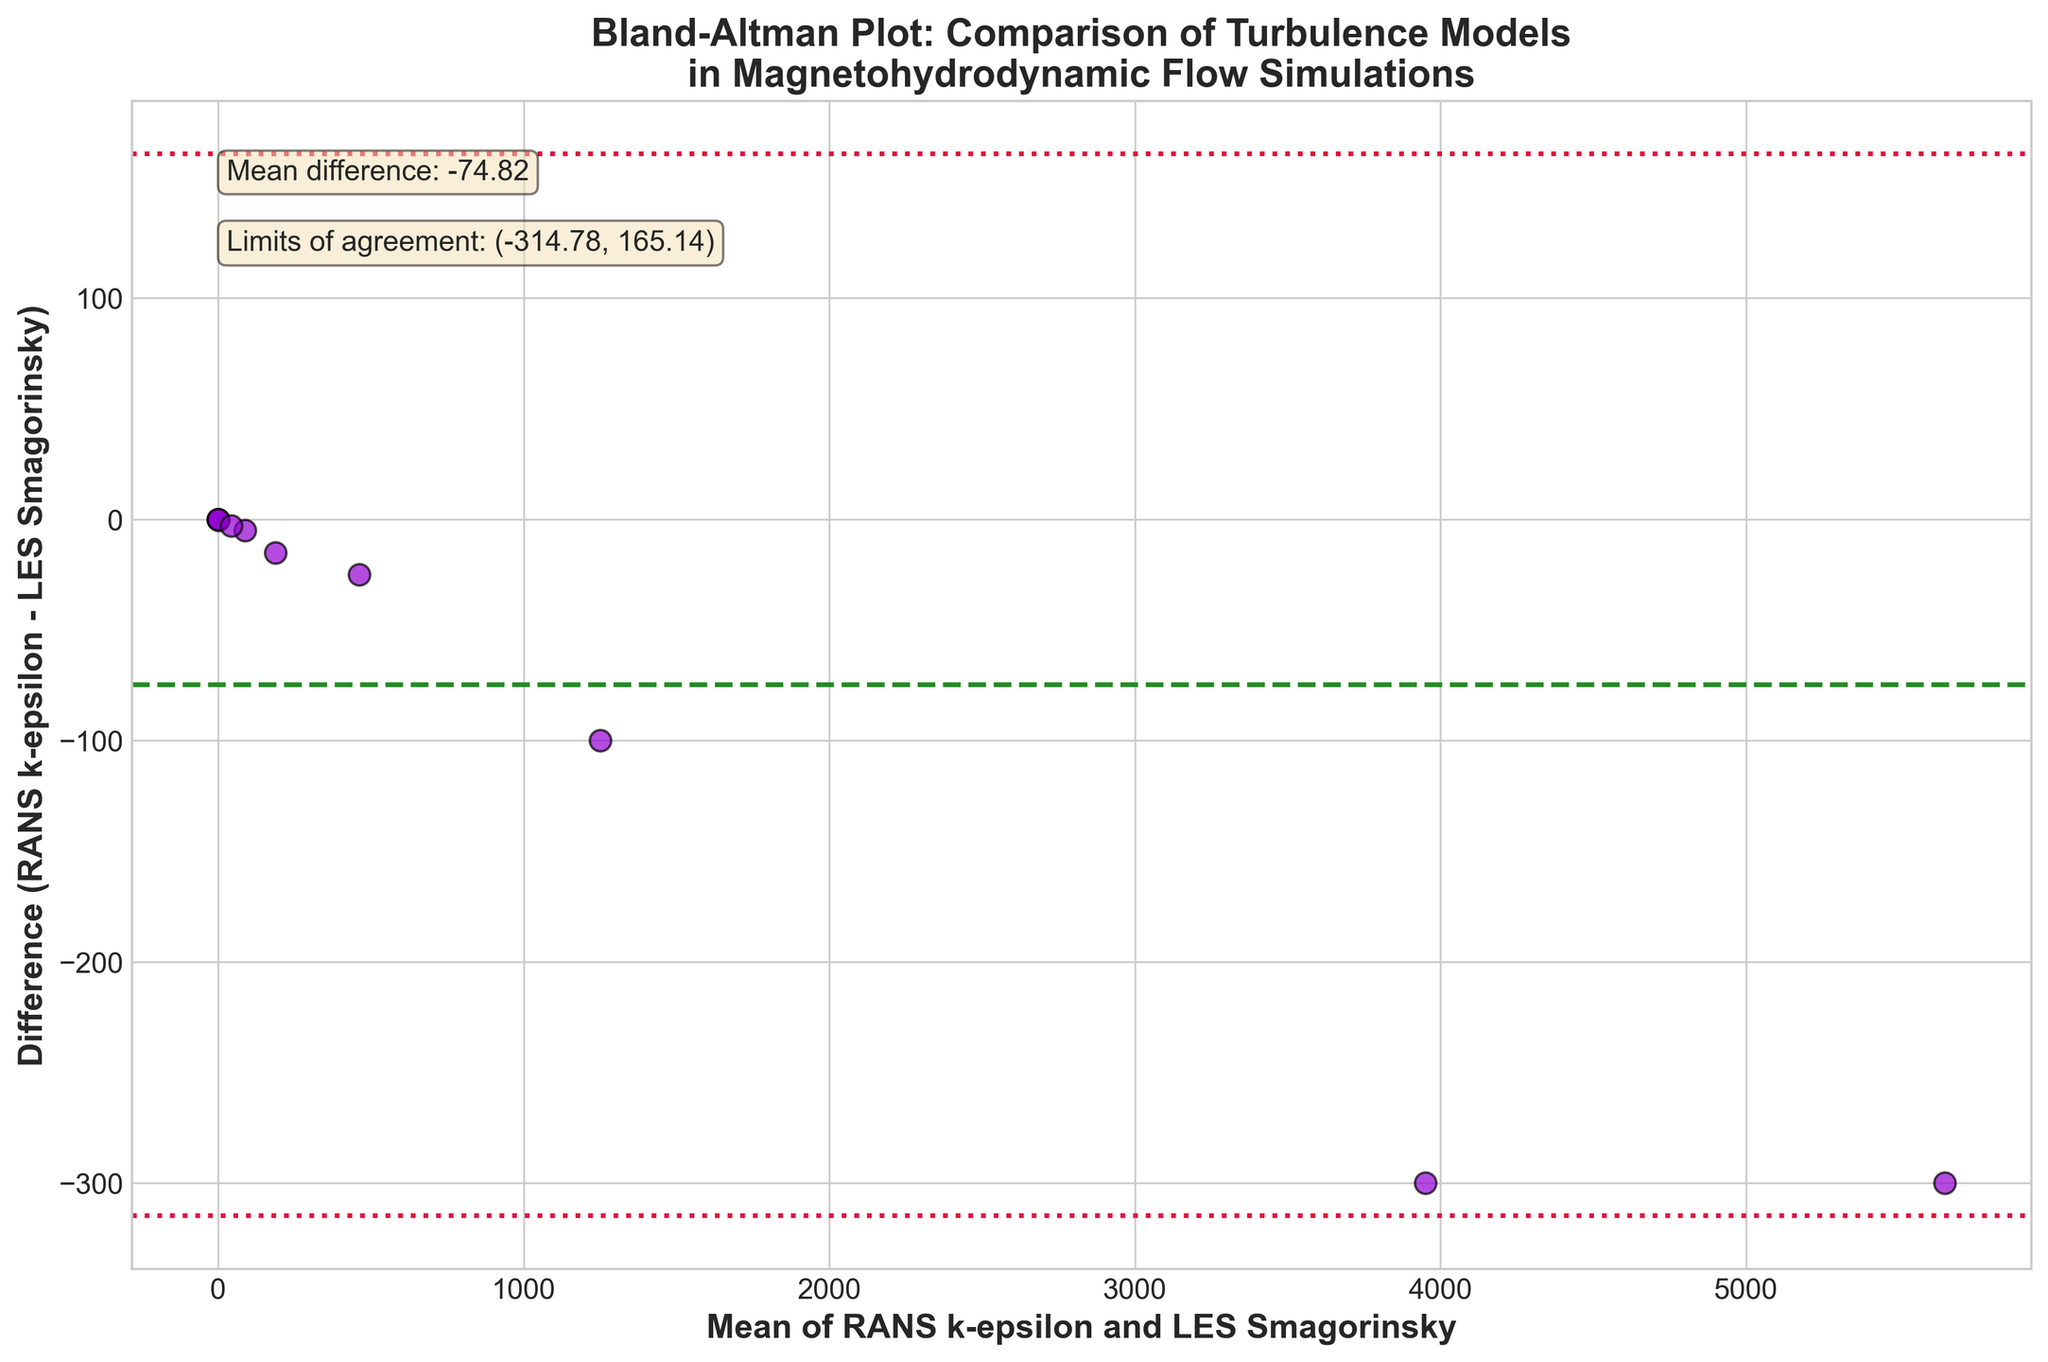What is the title of the plot? The title is usually placed at the top of the figure. Here it states "Bland-Altman Plot: Comparison of Turbulence Models in Magnetohydrodynamic Flow Simulations".
Answer: Bland-Altman Plot: Comparison of Turbulence Models in Magnetohydrodynamic Flow Simulations What are the x-axis and y-axis labels? Axis labels provide context for what the axes represent: the x-axis label is "Mean of RANS k-epsilon and LES Smagorinsky" and the y-axis label is "Difference (RANS k-epsilon - LES Smagorinsky)".
Answer: Mean of RANS k-epsilon and LES Smagorinsky, Difference (RANS k-epsilon - LES Smagorinsky) How many data points are plotted? Each scatter point represents a data pair from the given data set. Counting the scatter points will give the total number of data points; there are 10 plotted.
Answer: 10 What is the color of the scatter points and what does this signify? The color of scatter points is dark violet with black edges. The color itself does not signify any specific category but helps in visual distinction.
Answer: dark violet What does the dashed green line represent? The dashed green line depicts the mean difference between the RANS k-epsilon and LES Smagorinsky turbulence models, which is explicitly annotated in the plot.
Answer: the mean difference What are the values of the limits of agreement? These are depicted by the dotted crimson lines on the plot and are explicitly annotated. The limits of agreement are (mean_diff − 1.96 * std_diff, mean_diff + 1.96 * std_diff), with the values shown in the text box.
Answer: (−62.13, 7.73) Is the distribution of differences within the limits of agreement? Visual inspection shows whether most scatter points (differences) fall within the range of −62.13 to 7.73, indicated by the crimson lines.
Answer: Yes What can you infer about the agreement between the RANS k-epsilon and LES Smagorinsky models based on the plot? If most points are close to the mean difference line and within the limits of agreement, it indicates good agreement between the turbulence models.
Answer: The models show reasonable agreement How does the mean difference value affect the interpretation of the models' performances? The mean difference gives an overall bias between the two models. A value close to zero indicates minimal bias, whereas a larger absolute value shows significant deviation. The given mean difference is −27.20, indicating a small negative bias of RANS k-epsilon relative to LES Smagorinsky.
Answer: Indicates a small negative bias of RANS k-epsilon Which turbulence model tends to predict higher values based on the difference plot? By observing if the differences are mostly positive or negative, we can determine which model predicts higher. Since most points appear below zero on the y-axis, indicating that RANS k-epsilon values are generally lower than LES Smagorinsky predictions.
Answer: LES Smagorinsky 